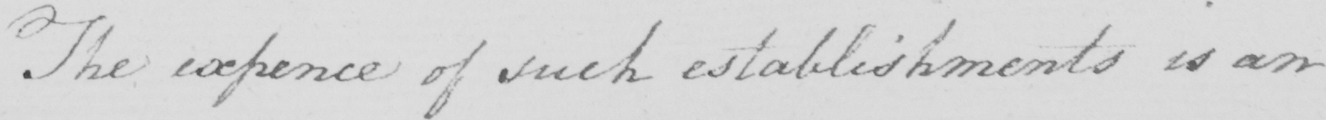Please provide the text content of this handwritten line. The expence of such establishments is an 